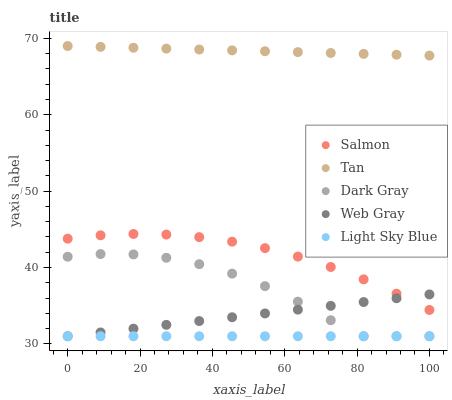Does Light Sky Blue have the minimum area under the curve?
Answer yes or no. Yes. Does Tan have the maximum area under the curve?
Answer yes or no. Yes. Does Web Gray have the minimum area under the curve?
Answer yes or no. No. Does Web Gray have the maximum area under the curve?
Answer yes or no. No. Is Light Sky Blue the smoothest?
Answer yes or no. Yes. Is Dark Gray the roughest?
Answer yes or no. Yes. Is Tan the smoothest?
Answer yes or no. No. Is Tan the roughest?
Answer yes or no. No. Does Dark Gray have the lowest value?
Answer yes or no. Yes. Does Tan have the lowest value?
Answer yes or no. No. Does Tan have the highest value?
Answer yes or no. Yes. Does Web Gray have the highest value?
Answer yes or no. No. Is Light Sky Blue less than Tan?
Answer yes or no. Yes. Is Salmon greater than Light Sky Blue?
Answer yes or no. Yes. Does Dark Gray intersect Web Gray?
Answer yes or no. Yes. Is Dark Gray less than Web Gray?
Answer yes or no. No. Is Dark Gray greater than Web Gray?
Answer yes or no. No. Does Light Sky Blue intersect Tan?
Answer yes or no. No. 